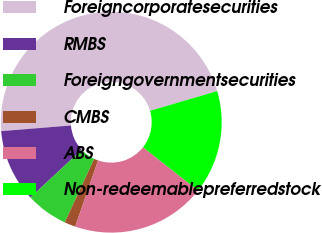<chart> <loc_0><loc_0><loc_500><loc_500><pie_chart><fcel>Foreigncorporatesecurities<fcel>RMBS<fcel>Foreigngovernmentsecurities<fcel>CMBS<fcel>ABS<fcel>Non-redeemablepreferredstock<nl><fcel>46.73%<fcel>10.65%<fcel>6.14%<fcel>1.63%<fcel>19.67%<fcel>15.16%<nl></chart> 